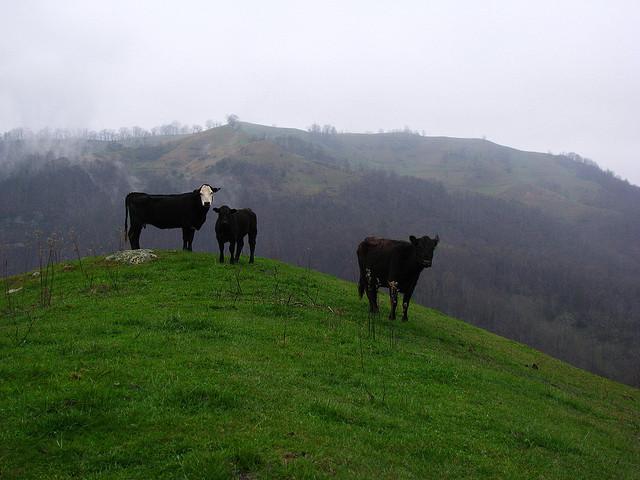What animals are these?
Concise answer only. Cows. Is it sunny?
Quick response, please. No. Is the greenery grass?
Keep it brief. Yes. How many cows?
Concise answer only. 3. Is there a photoshoot?
Keep it brief. No. Is the cow waiting for someone?
Give a very brief answer. No. Is this photo taken in a zoo area?
Be succinct. No. Are there any calves in the picture?
Short answer required. Yes. How many cows are there?
Write a very short answer. 3. How many cows in the field?
Short answer required. 3. How many pairs of cow ears are visible?
Concise answer only. 3. Are the cows sleeping?
Concise answer only. No. Is the cow alone?
Write a very short answer. No. 